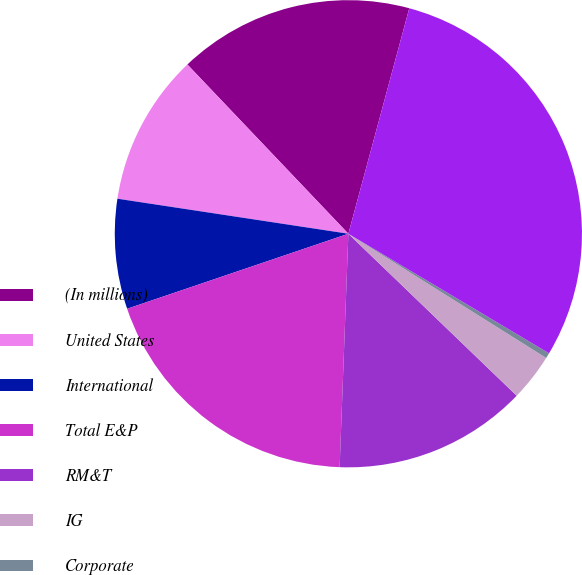<chart> <loc_0><loc_0><loc_500><loc_500><pie_chart><fcel>(In millions)<fcel>United States<fcel>International<fcel>Total E&P<fcel>RM&T<fcel>IG<fcel>Corporate<fcel>Total<nl><fcel>16.3%<fcel>10.5%<fcel>7.6%<fcel>19.2%<fcel>13.4%<fcel>3.27%<fcel>0.37%<fcel>29.35%<nl></chart> 